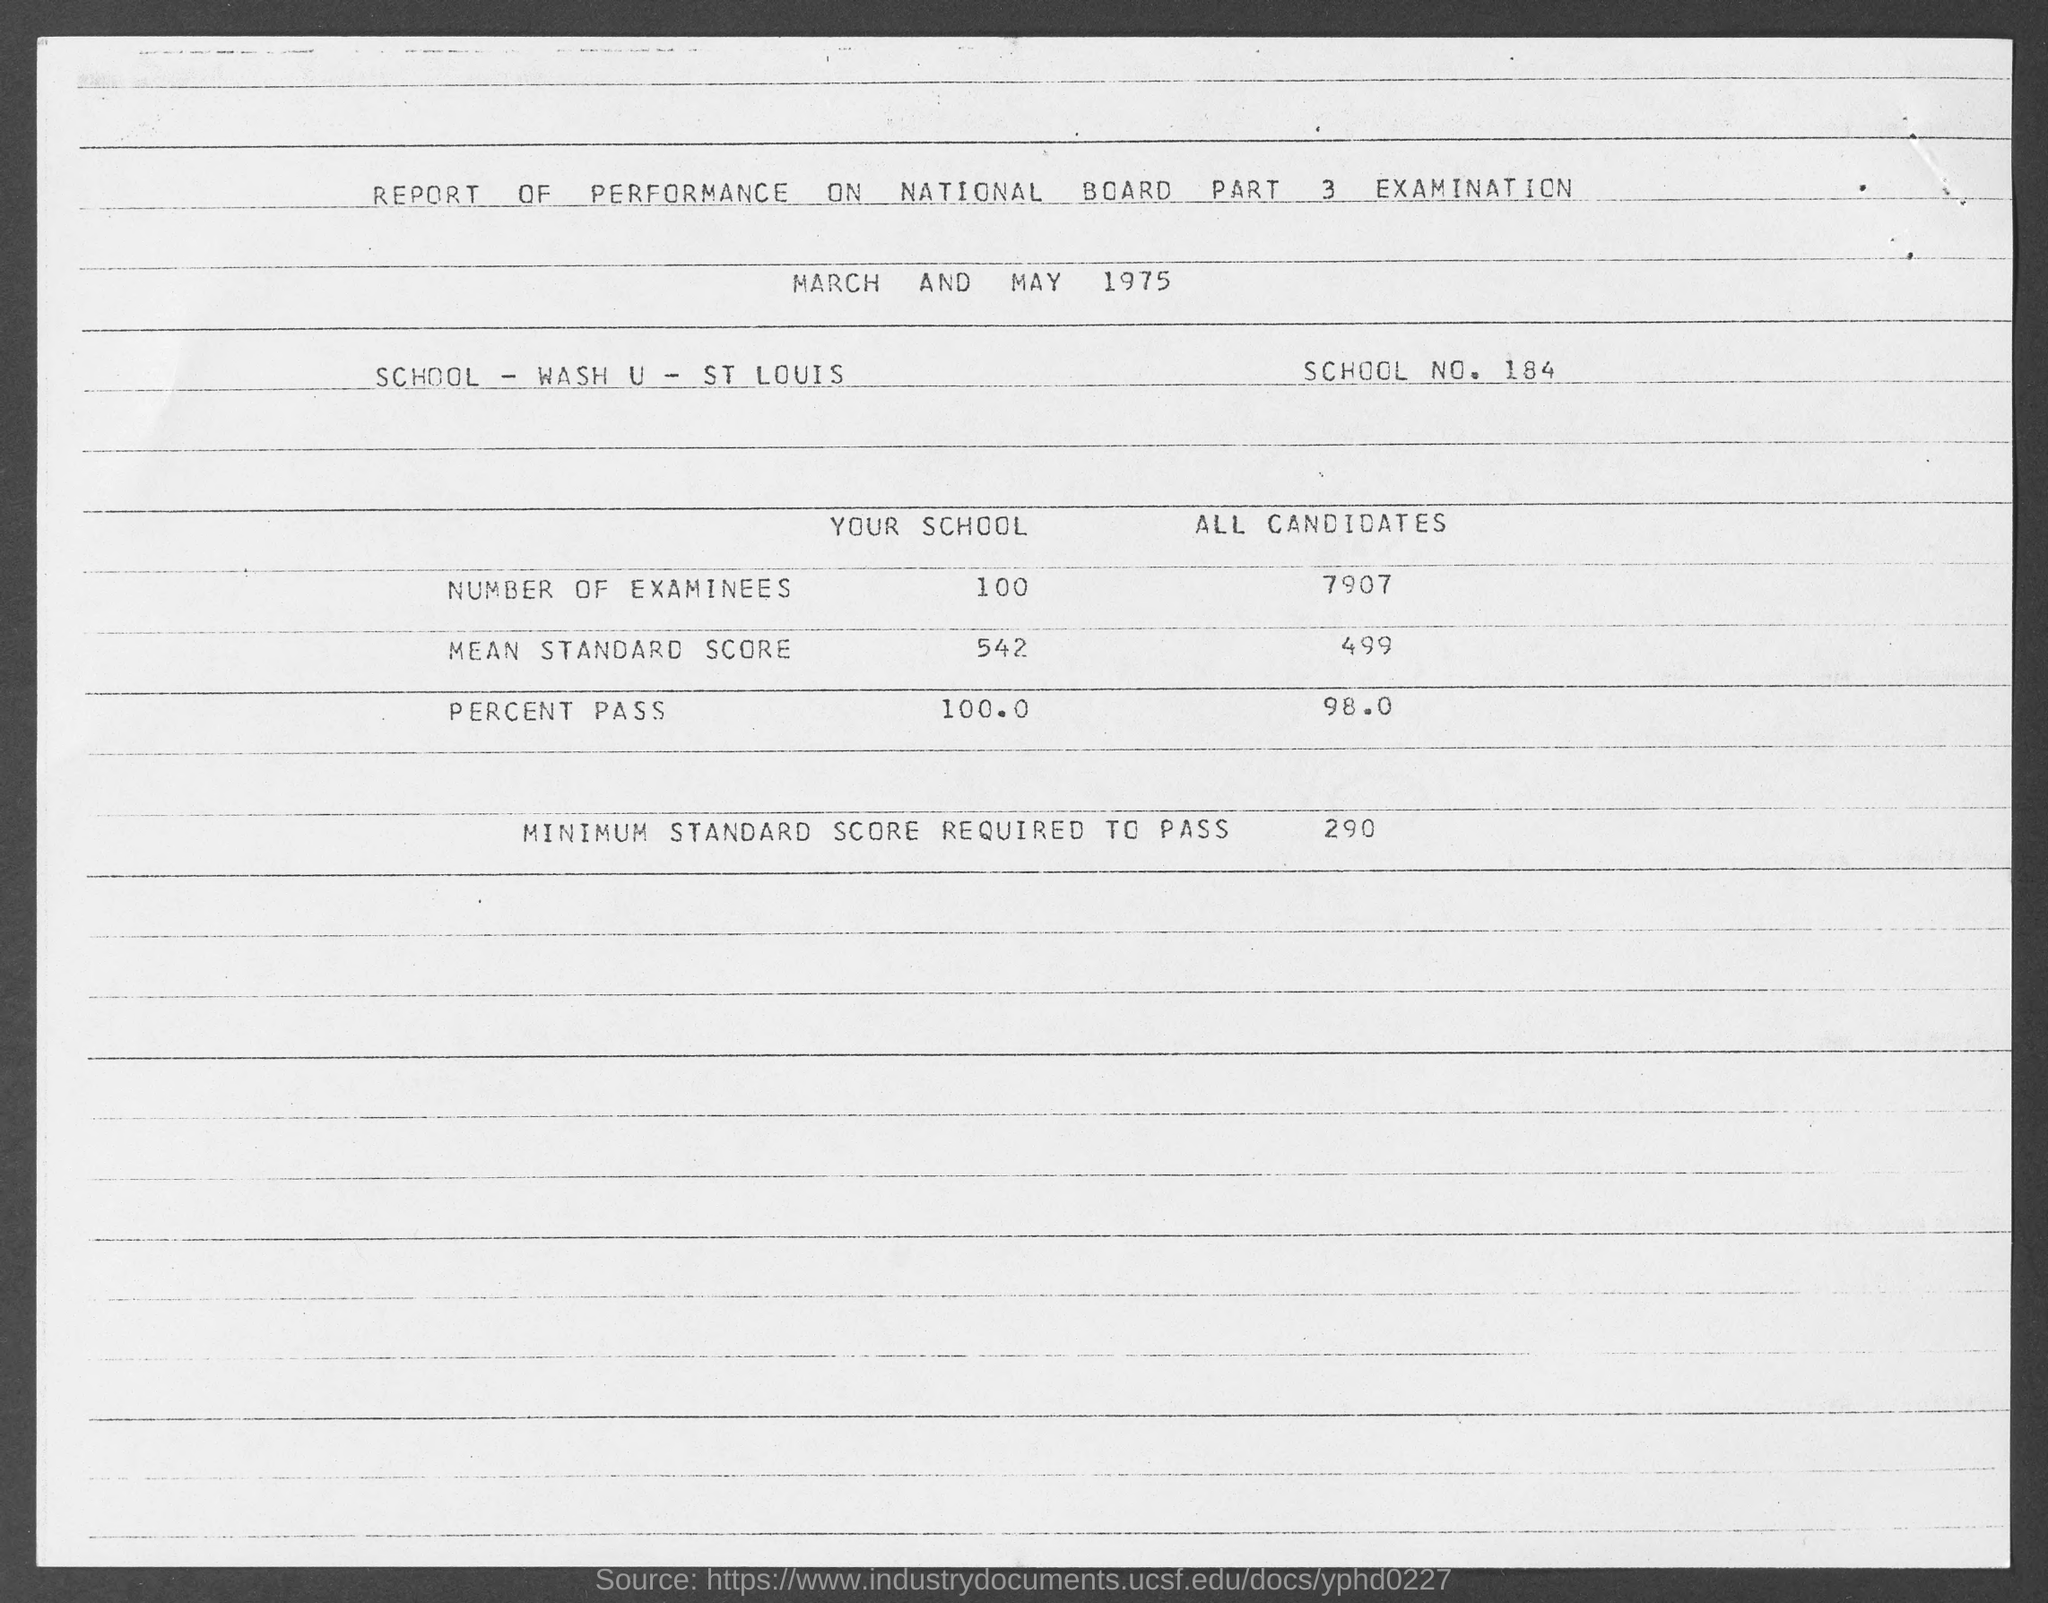List a handful of essential elements in this visual. The percent pass of all candidates is 98%. Wash U - St. Louis is the school that is being referred to. The document title is a report of performance on a National Board Part 3 Examination. What is the school number? It is 184... The minimum standard score required to pass is 290. 